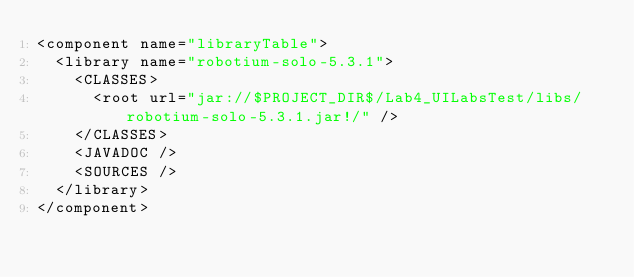<code> <loc_0><loc_0><loc_500><loc_500><_XML_><component name="libraryTable">
  <library name="robotium-solo-5.3.1">
    <CLASSES>
      <root url="jar://$PROJECT_DIR$/Lab4_UILabsTest/libs/robotium-solo-5.3.1.jar!/" />
    </CLASSES>
    <JAVADOC />
    <SOURCES />
  </library>
</component></code> 